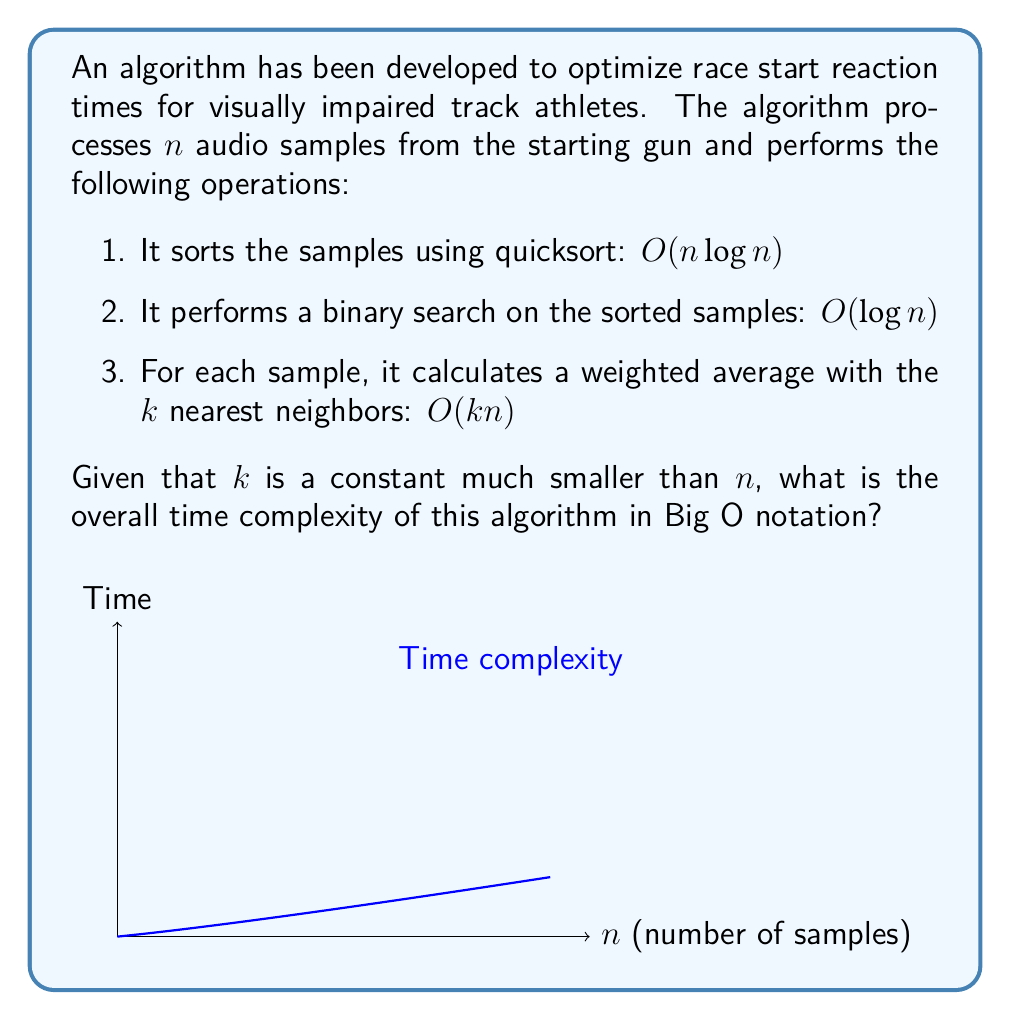Solve this math problem. To determine the overall time complexity, we need to analyze each step of the algorithm:

1. Sorting using quicksort: $O(n \log n)$
   This is the average-case time complexity for quicksort.

2. Binary search: $O(\log n)$
   Binary search on a sorted array of $n$ elements has logarithmic time complexity.

3. Weighted average calculation: $O(kn)$
   For each of the $n$ samples, we perform $k$ operations. Since $k$ is a constant, this simplifies to $O(n)$.

Now, we need to combine these complexities:

$$O(n \log n) + O(\log n) + O(n)$$

To determine the dominant term, we compare the growth rates:

- $O(n \log n)$ grows faster than $O(n)$
- $O(n \log n)$ grows faster than $O(\log n)$

Therefore, the dominant term is $O(n \log n)$.

The constant $k$ and the lower-order terms can be dropped in Big O notation, leaving us with the final time complexity of $O(n \log n)$.
Answer: $O(n \log n)$ 